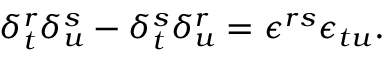<formula> <loc_0><loc_0><loc_500><loc_500>\delta _ { t } ^ { r } \delta _ { u } ^ { s } - \delta _ { t } ^ { s } \delta _ { u } ^ { r } = \epsilon ^ { r s } \epsilon _ { t u } .</formula> 